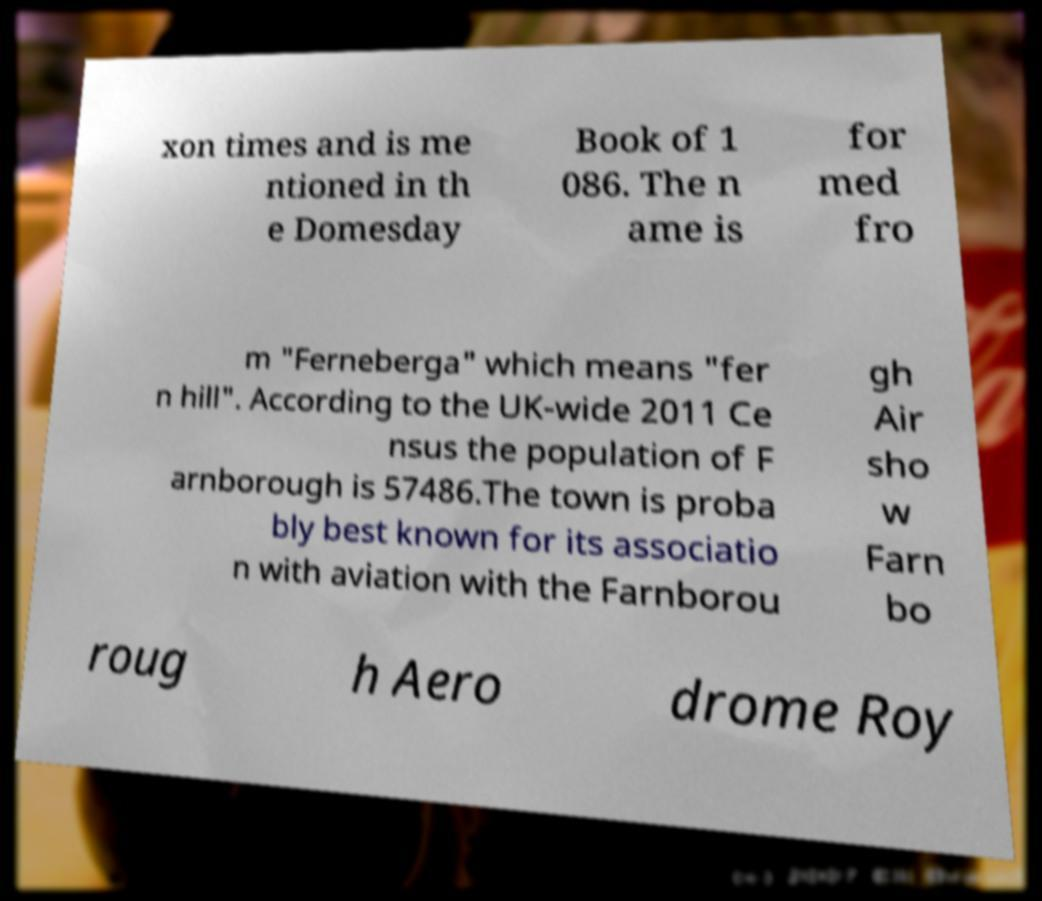For documentation purposes, I need the text within this image transcribed. Could you provide that? xon times and is me ntioned in th e Domesday Book of 1 086. The n ame is for med fro m "Ferneberga" which means "fer n hill". According to the UK-wide 2011 Ce nsus the population of F arnborough is 57486.The town is proba bly best known for its associatio n with aviation with the Farnborou gh Air sho w Farn bo roug h Aero drome Roy 